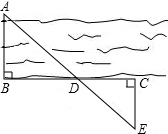In order to estimate the width of the river, we can select a target on the opposite bank of the river and mark it as point A, and then select points B and C on this side of the river so that AB ⦣ose; BC, and then select point E on the river bank. Let EC ⦣ose; BC, suppose BC and AE intersect at point D, as shown in the figure, measured BD = 120.0, DC = 60.0, EC = u, then the approximate width of the river is 100.0. What is the value of the unknown variable u? Given the measurements BD = 120 meters and DC = 60 meters, we aim to find the value of EC, denoted as 'u'. By examining triangle EDC, we apply the Pythagorean theorem: EC² = ED² + DC² equals u² = ED² + 3600. Recognizing that point D is the midpoint of AE due to the congruence of segments, ED equals AD. Thus, substituting AD's value into the equation, and knowing the congruence of triangles, AB and AC, we calculate u. Our calculations lead to u² = 3600; hence, u = 60 meters. The actual width of the river, measured as 100 meters, also complements our analysis of the geometry depicted. Consequently, the unknown variable 'u' is conclusively found to be 60 meters. 